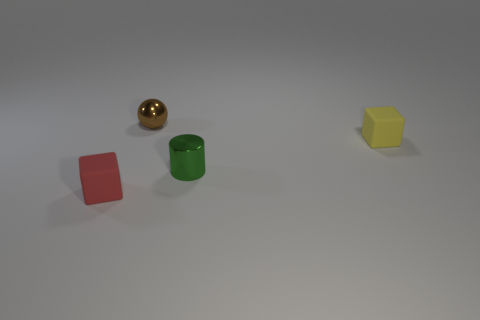There is a rubber object that is behind the red thing; how big is it?
Keep it short and to the point. Small. Are there fewer tiny rubber objects left of the small brown metal thing than tiny things that are behind the tiny red thing?
Give a very brief answer. Yes. What is the color of the tiny cylinder?
Provide a short and direct response. Green. Is there a big shiny ball of the same color as the cylinder?
Your answer should be very brief. No. There is a small brown metal thing that is on the right side of the small matte object on the left side of the yellow matte object behind the green metal cylinder; what is its shape?
Provide a succinct answer. Sphere. There is a thing that is behind the small yellow cube; what is its material?
Offer a terse response. Metal. There is a cube that is to the right of the small metal thing on the left side of the metallic thing right of the small shiny ball; what is its size?
Keep it short and to the point. Small. There is a small rubber block that is to the left of the green metal object; what color is it?
Keep it short and to the point. Red. There is a small matte object that is to the left of the tiny brown metal ball; what is its shape?
Offer a very short reply. Cube. What number of green things are either small cylinders or tiny matte cubes?
Provide a short and direct response. 1. 